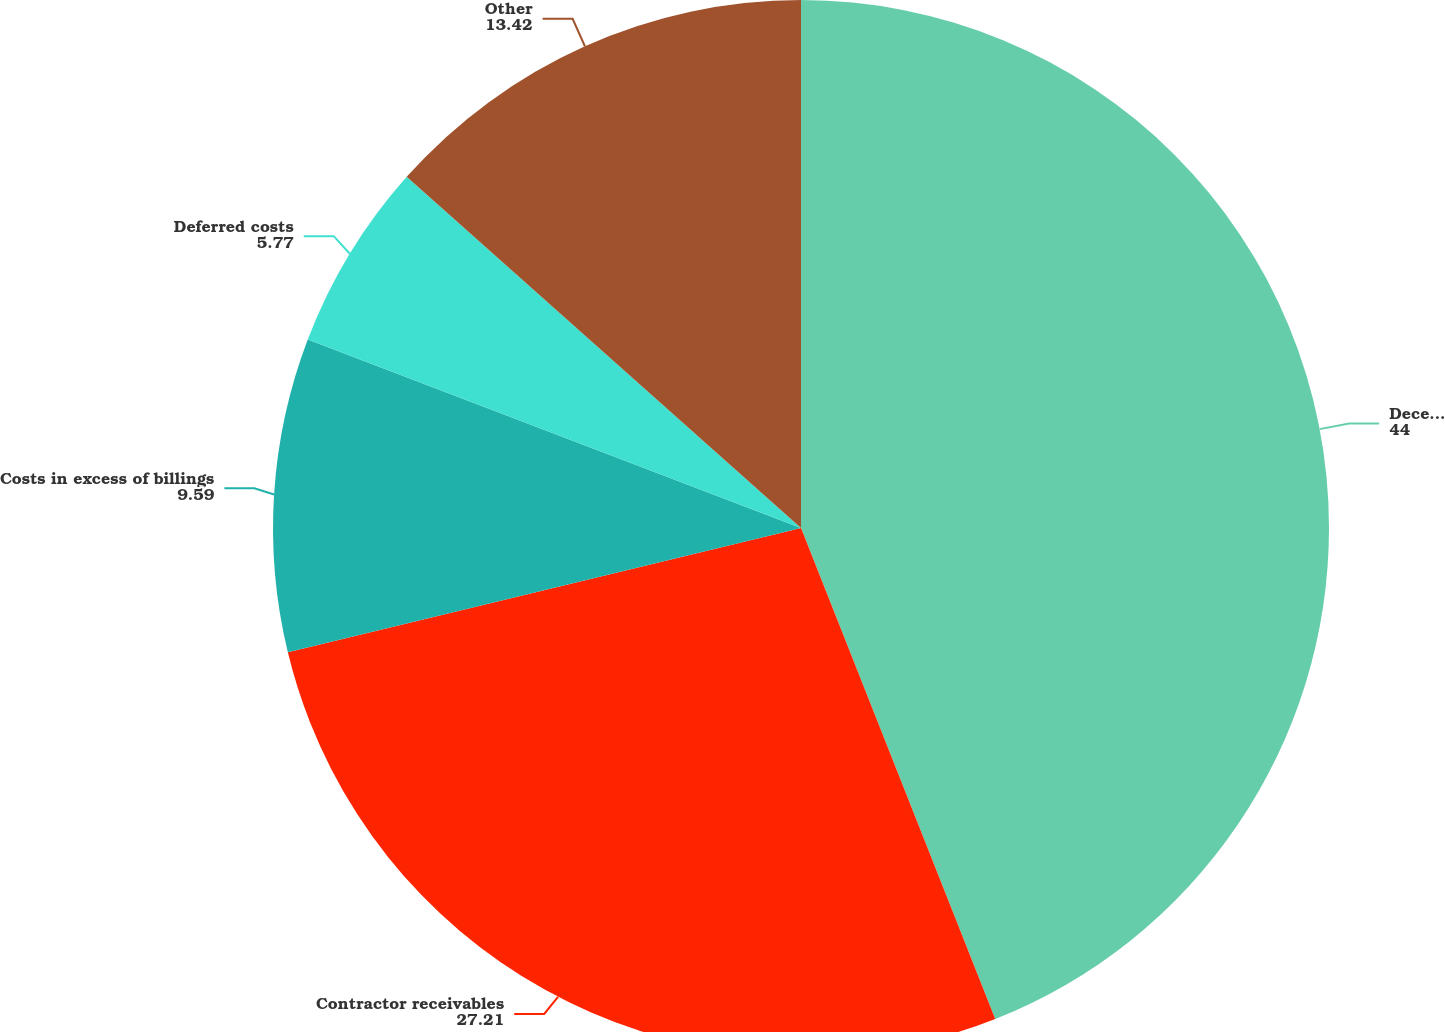Convert chart. <chart><loc_0><loc_0><loc_500><loc_500><pie_chart><fcel>December 31<fcel>Contractor receivables<fcel>Costs in excess of billings<fcel>Deferred costs<fcel>Other<nl><fcel>44.0%<fcel>27.21%<fcel>9.59%<fcel>5.77%<fcel>13.42%<nl></chart> 